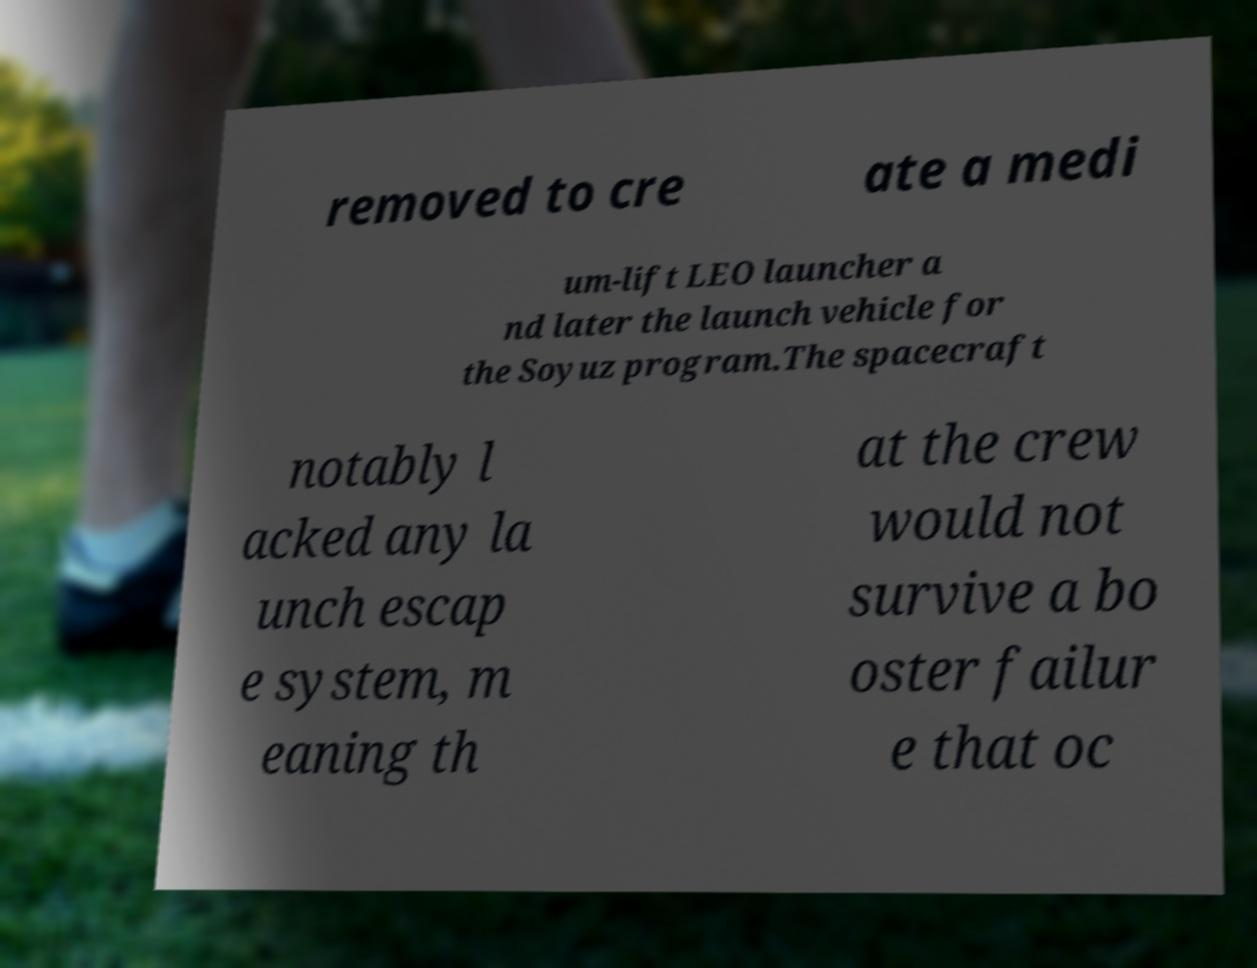I need the written content from this picture converted into text. Can you do that? removed to cre ate a medi um-lift LEO launcher a nd later the launch vehicle for the Soyuz program.The spacecraft notably l acked any la unch escap e system, m eaning th at the crew would not survive a bo oster failur e that oc 